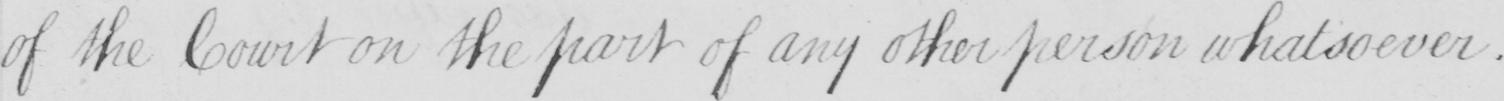Can you read and transcribe this handwriting? of the Court on the part of any other person whatsoever . 